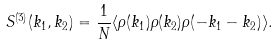<formula> <loc_0><loc_0><loc_500><loc_500>S ^ { ( 3 ) } ( { k } _ { 1 } , { k } _ { 2 } ) = \frac { 1 } { N } \langle \rho ( { k } _ { 1 } ) \rho ( { k } _ { 2 } ) \rho ( - { k } _ { 1 } - { k } _ { 2 } ) \rangle .</formula> 